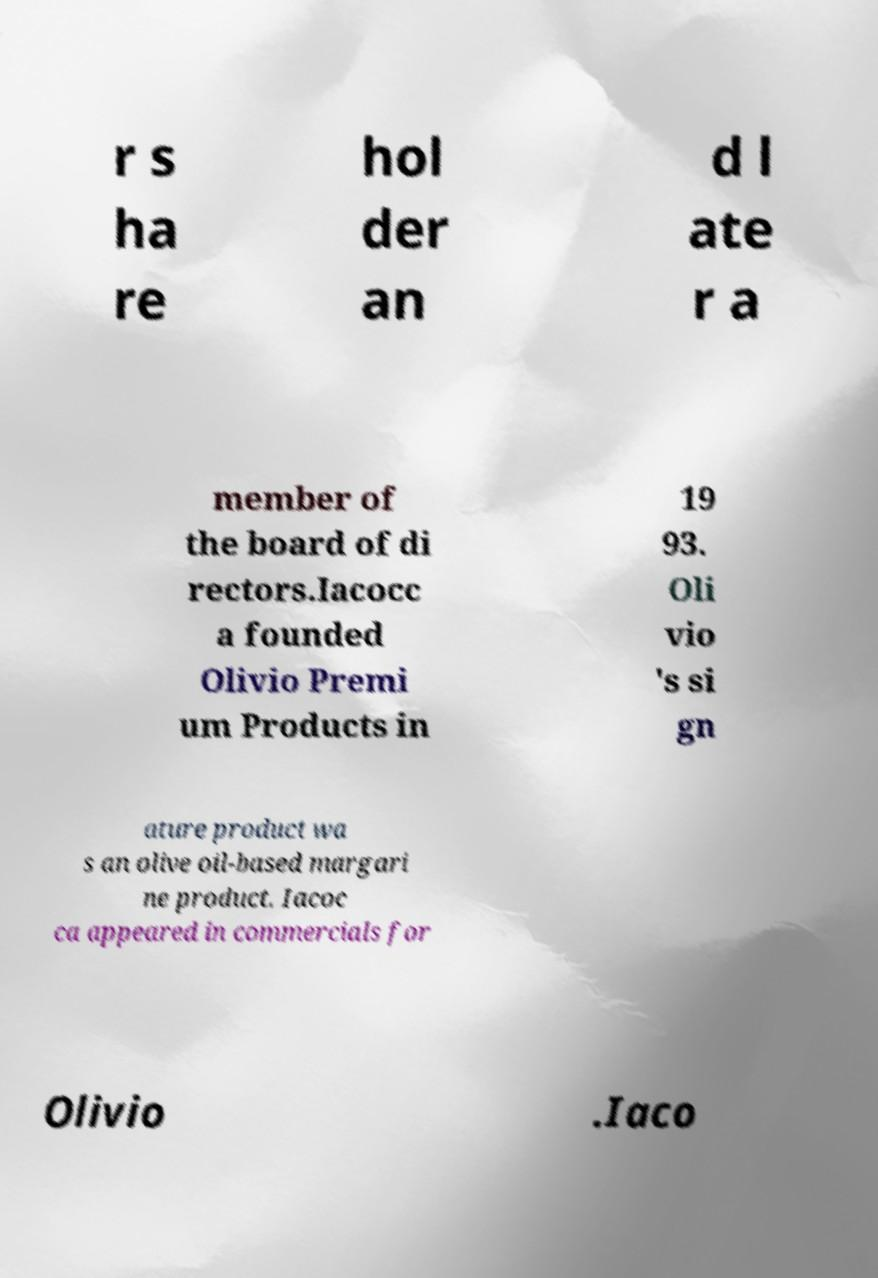Can you read and provide the text displayed in the image?This photo seems to have some interesting text. Can you extract and type it out for me? r s ha re hol der an d l ate r a member of the board of di rectors.Iacocc a founded Olivio Premi um Products in 19 93. Oli vio 's si gn ature product wa s an olive oil-based margari ne product. Iacoc ca appeared in commercials for Olivio .Iaco 